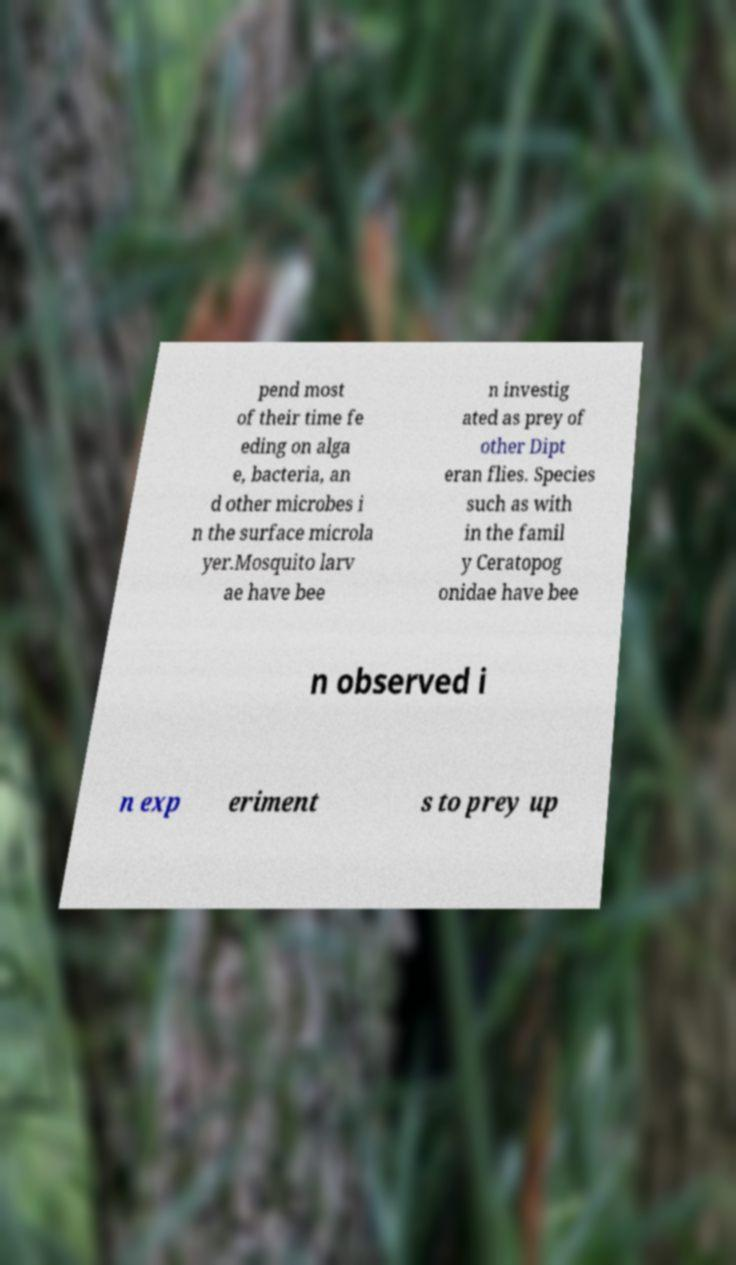Could you assist in decoding the text presented in this image and type it out clearly? pend most of their time fe eding on alga e, bacteria, an d other microbes i n the surface microla yer.Mosquito larv ae have bee n investig ated as prey of other Dipt eran flies. Species such as with in the famil y Ceratopog onidae have bee n observed i n exp eriment s to prey up 